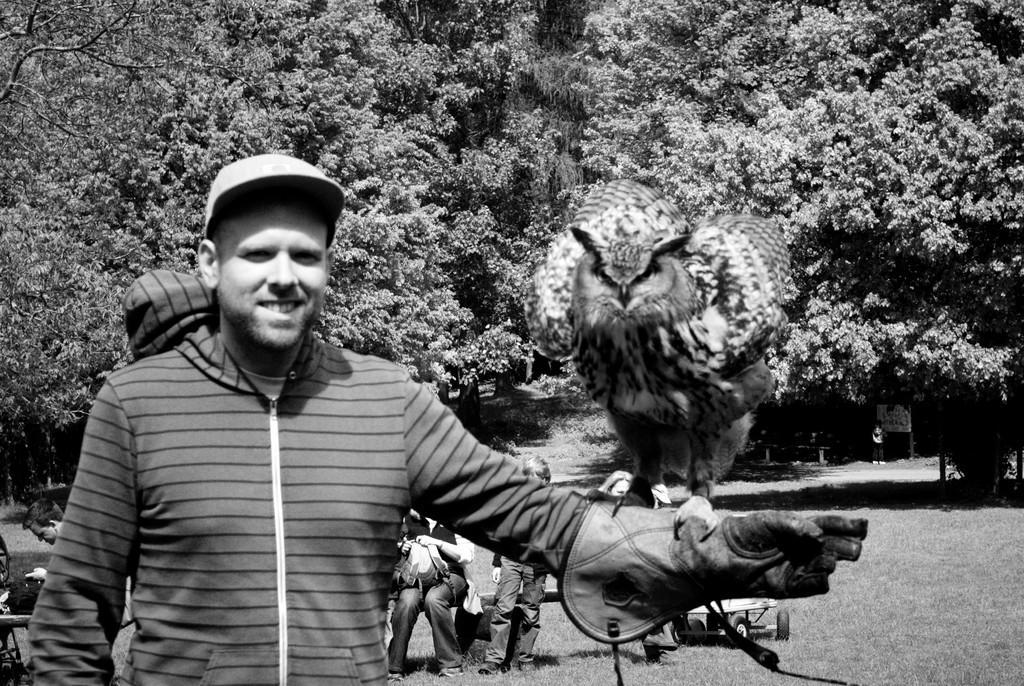In one or two sentences, can you explain what this image depicts? In this picture there is a man who is standing in the left side of the image and there is a bird on his hand, there are people those who are sitting on the left side of the image, there is grass land at the bottom side of the image and there are trees in the background area of the image. 